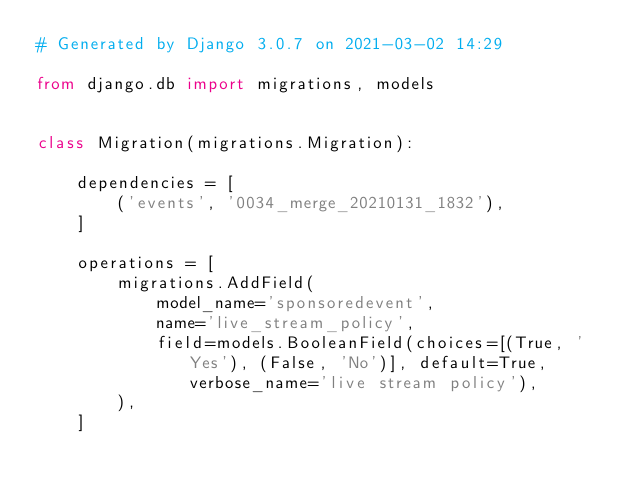Convert code to text. <code><loc_0><loc_0><loc_500><loc_500><_Python_># Generated by Django 3.0.7 on 2021-03-02 14:29

from django.db import migrations, models


class Migration(migrations.Migration):

    dependencies = [
        ('events', '0034_merge_20210131_1832'),
    ]

    operations = [
        migrations.AddField(
            model_name='sponsoredevent',
            name='live_stream_policy',
            field=models.BooleanField(choices=[(True, 'Yes'), (False, 'No')], default=True, verbose_name='live stream policy'),
        ),
    ]
</code> 